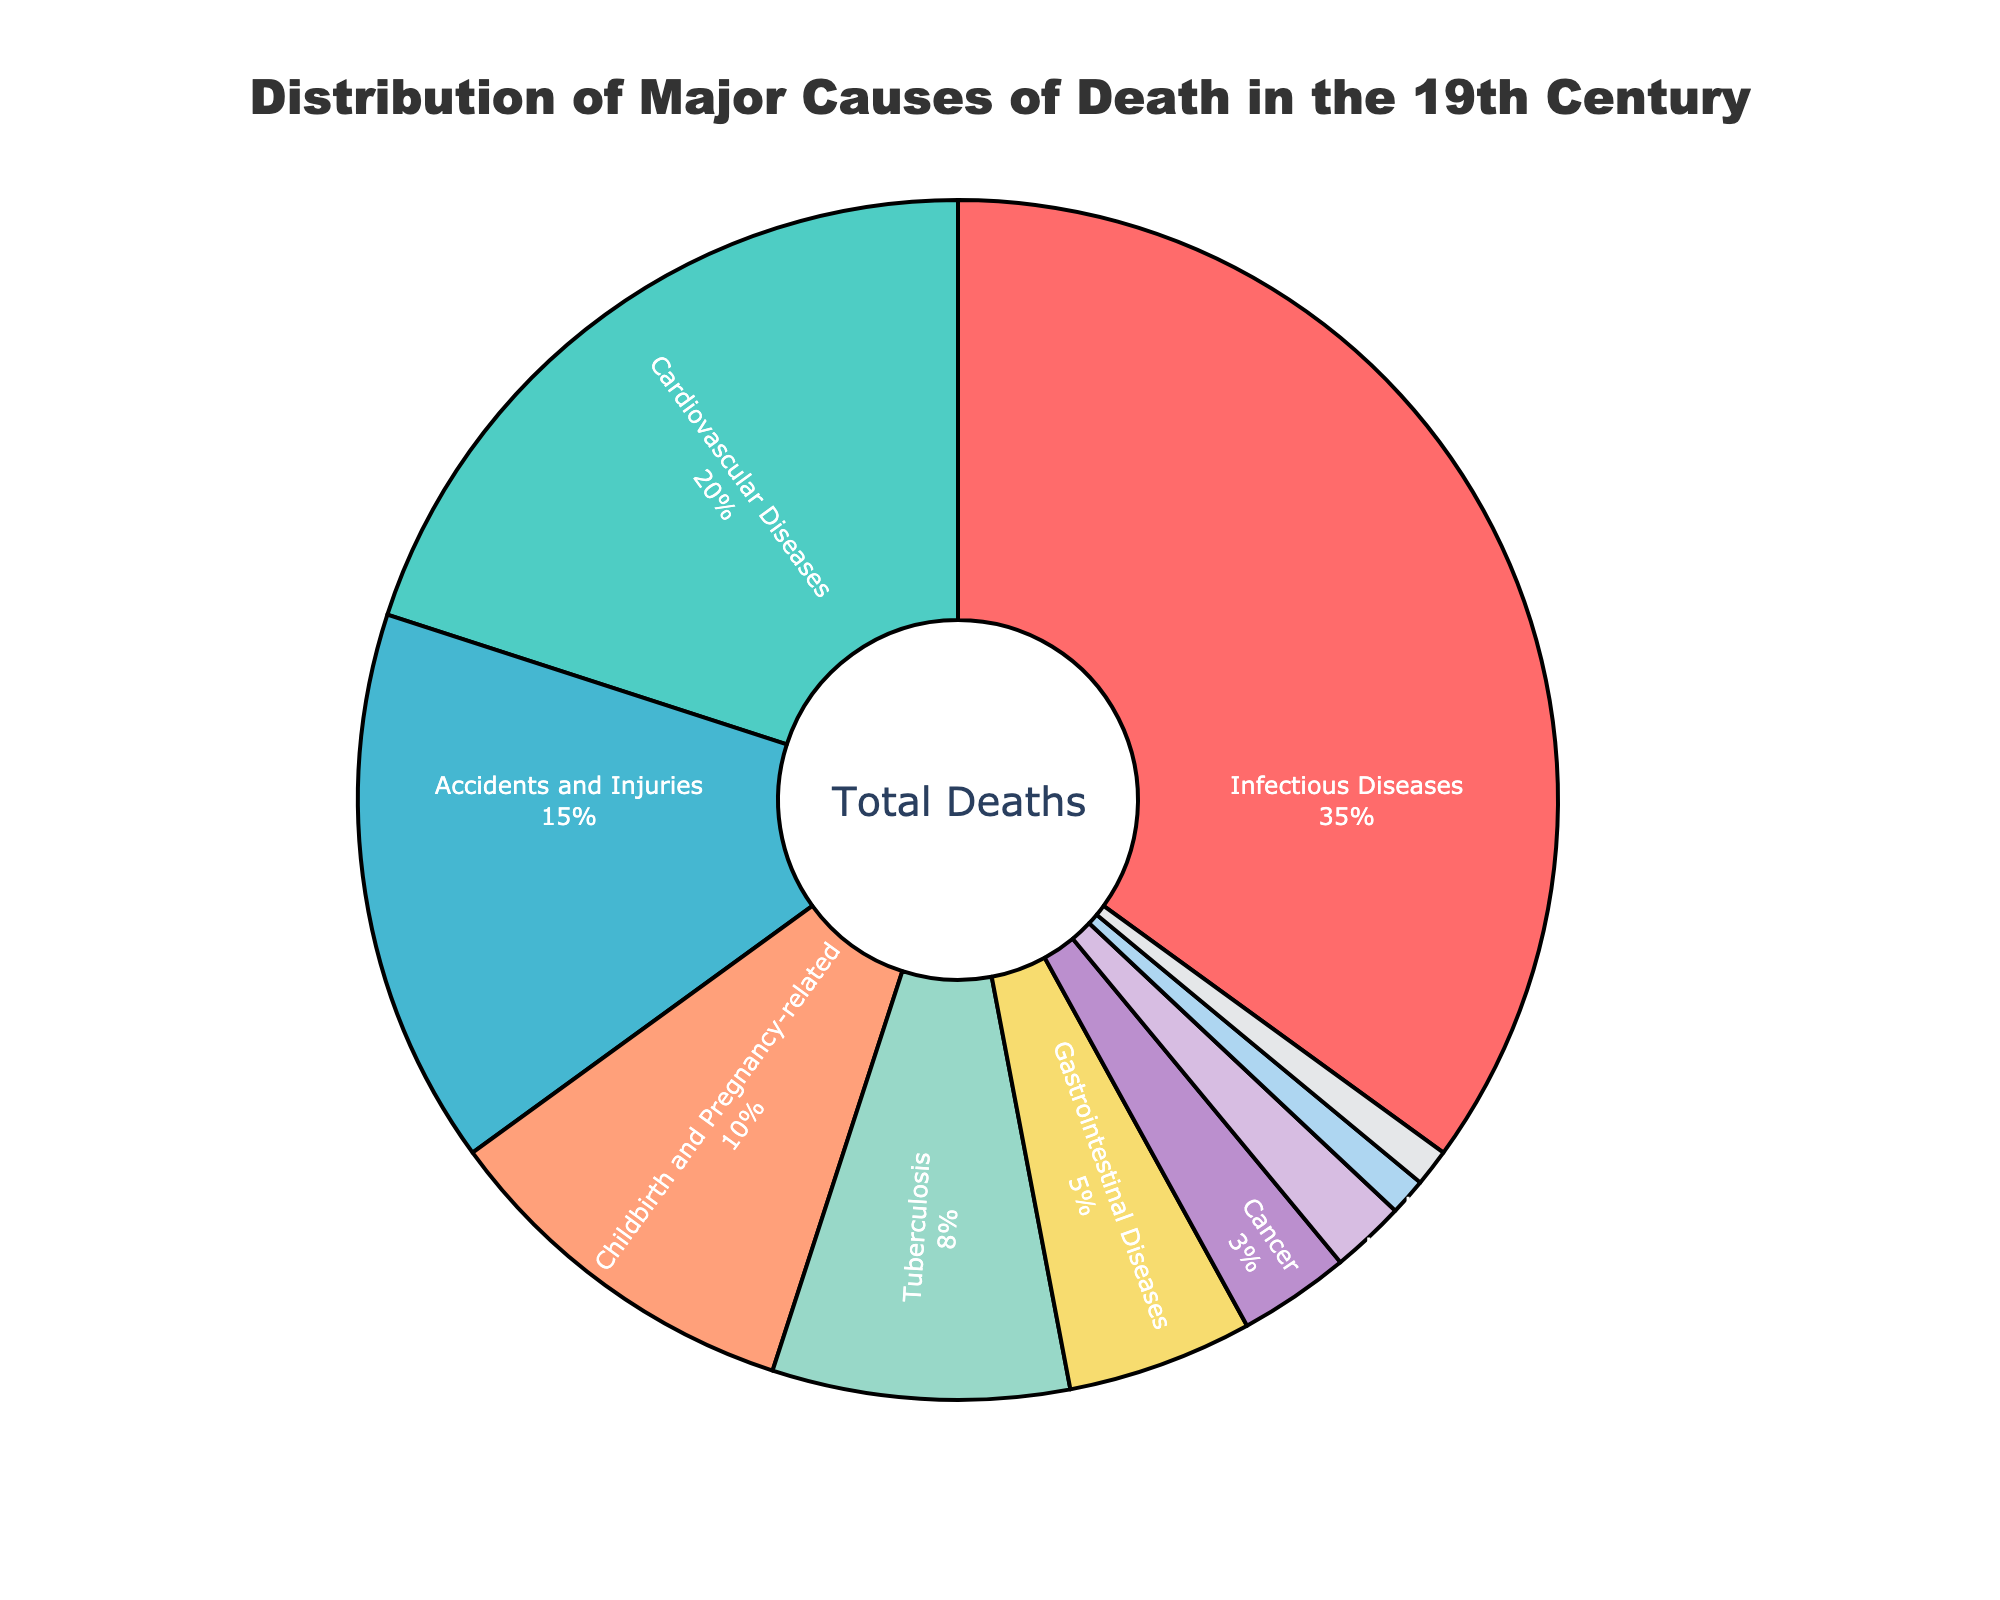What is the percentage of deaths caused by Infectious Diseases? The sector labeled "Infectious Diseases" shows a percentage value, which is 35%.
Answer: 35% Which cause of death ranks second in percentage? By observing the pie chart, the sector labeled "Cardiovascular Diseases" is the second largest, which has a percentage value of 20%.
Answer: Cardiovascular Diseases How much more prevalent are Infectious Diseases compared to Cancer? Subtract the percentage of deaths caused by Cancer (3%) from the percentage of deaths caused by Infectious Diseases (35%). 35 - 3 = 32%.
Answer: 32% Which color represents Accidents and Injuries? The sector labeled "Accidents and Injuries" is marked with the corresponding color, which is a light blue shade.
Answer: Light Blue What is the combined percentage of deaths caused by Tuberculosis, Malnutrition, and Respiratory Diseases? Add the percentages for Tuberculosis (8%), Malnutrition (2%), and Respiratory Diseases (1%). 8 + 2 + 1 = 11%.
Answer: 11% Is the percentage of deaths from Childbirth and Pregnancy-related causes greater than that from Gastrointestinal Diseases? Compare the percentages: Childbirth and Pregnancy-related causes are at 10%, and Gastrointestinal Diseases are at 5%. 10% is greater than 5%.
Answer: Yes How does the percentage of deaths from Unknown Causes compare to Respiratory Diseases? Both sectors are labeled with the same percentage value of 1%, meaning they are equal.
Answer: Equal What is the difference in the percentage of deaths between Cardiovascular Diseases and Gastrointestinal Diseases? Subtract the percentage of Gastrointestinal Diseases (5%) from the percentage of Cardiovascular Diseases (20%). 20 - 5 = 15%.
Answer: 15% Which section appears the smallest and what is its percentage? The smallest section in visual size is marked for Respiratory Diseases and Unknown Causes, both at 1%.
Answer: Respiratory Diseases and Unknown Causes, 1% What is the total percentage of deaths covered by the three largest causes? Sum the percentages of the top three causes: Infectious Diseases (35%), Cardiovascular Diseases (20%), and Accidents and Injuries (15%). 35 + 20 + 15 = 70%.
Answer: 70% 